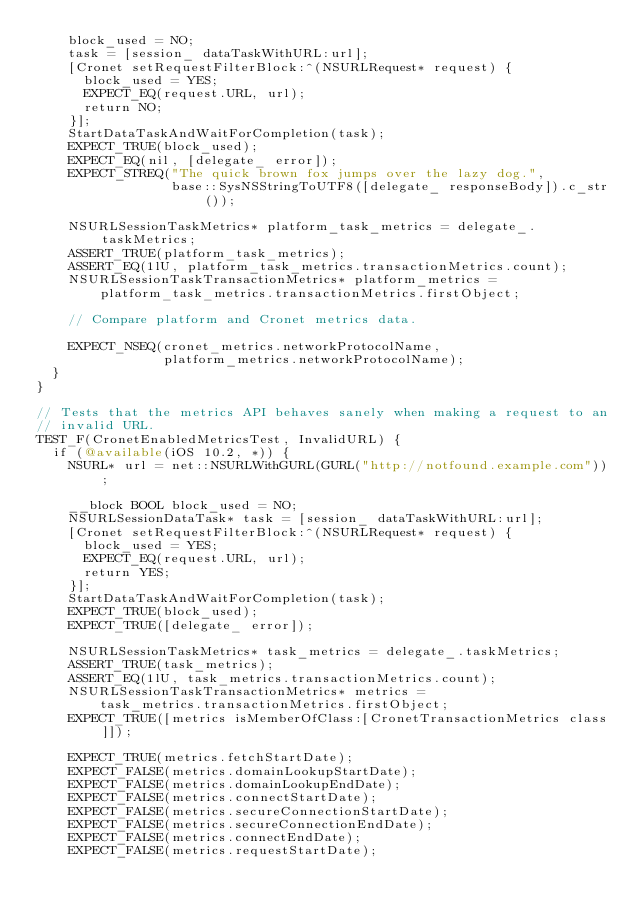Convert code to text. <code><loc_0><loc_0><loc_500><loc_500><_ObjectiveC_>    block_used = NO;
    task = [session_ dataTaskWithURL:url];
    [Cronet setRequestFilterBlock:^(NSURLRequest* request) {
      block_used = YES;
      EXPECT_EQ(request.URL, url);
      return NO;
    }];
    StartDataTaskAndWaitForCompletion(task);
    EXPECT_TRUE(block_used);
    EXPECT_EQ(nil, [delegate_ error]);
    EXPECT_STREQ("The quick brown fox jumps over the lazy dog.",
                 base::SysNSStringToUTF8([delegate_ responseBody]).c_str());

    NSURLSessionTaskMetrics* platform_task_metrics = delegate_.taskMetrics;
    ASSERT_TRUE(platform_task_metrics);
    ASSERT_EQ(1lU, platform_task_metrics.transactionMetrics.count);
    NSURLSessionTaskTransactionMetrics* platform_metrics =
        platform_task_metrics.transactionMetrics.firstObject;

    // Compare platform and Cronet metrics data.

    EXPECT_NSEQ(cronet_metrics.networkProtocolName,
                platform_metrics.networkProtocolName);
  }
}

// Tests that the metrics API behaves sanely when making a request to an
// invalid URL.
TEST_F(CronetEnabledMetricsTest, InvalidURL) {
  if (@available(iOS 10.2, *)) {
    NSURL* url = net::NSURLWithGURL(GURL("http://notfound.example.com"));

    __block BOOL block_used = NO;
    NSURLSessionDataTask* task = [session_ dataTaskWithURL:url];
    [Cronet setRequestFilterBlock:^(NSURLRequest* request) {
      block_used = YES;
      EXPECT_EQ(request.URL, url);
      return YES;
    }];
    StartDataTaskAndWaitForCompletion(task);
    EXPECT_TRUE(block_used);
    EXPECT_TRUE([delegate_ error]);

    NSURLSessionTaskMetrics* task_metrics = delegate_.taskMetrics;
    ASSERT_TRUE(task_metrics);
    ASSERT_EQ(1lU, task_metrics.transactionMetrics.count);
    NSURLSessionTaskTransactionMetrics* metrics =
        task_metrics.transactionMetrics.firstObject;
    EXPECT_TRUE([metrics isMemberOfClass:[CronetTransactionMetrics class]]);

    EXPECT_TRUE(metrics.fetchStartDate);
    EXPECT_FALSE(metrics.domainLookupStartDate);
    EXPECT_FALSE(metrics.domainLookupEndDate);
    EXPECT_FALSE(metrics.connectStartDate);
    EXPECT_FALSE(metrics.secureConnectionStartDate);
    EXPECT_FALSE(metrics.secureConnectionEndDate);
    EXPECT_FALSE(metrics.connectEndDate);
    EXPECT_FALSE(metrics.requestStartDate);</code> 